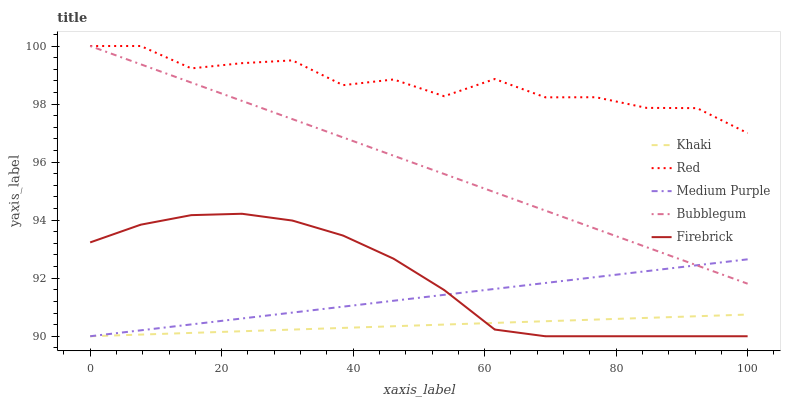Does Firebrick have the minimum area under the curve?
Answer yes or no. No. Does Firebrick have the maximum area under the curve?
Answer yes or no. No. Is Firebrick the smoothest?
Answer yes or no. No. Is Firebrick the roughest?
Answer yes or no. No. Does Bubblegum have the lowest value?
Answer yes or no. No. Does Firebrick have the highest value?
Answer yes or no. No. Is Khaki less than Red?
Answer yes or no. Yes. Is Bubblegum greater than Firebrick?
Answer yes or no. Yes. Does Khaki intersect Red?
Answer yes or no. No. 